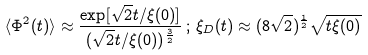Convert formula to latex. <formula><loc_0><loc_0><loc_500><loc_500>\langle \Phi ^ { 2 } ( t ) \rangle \approx \frac { \exp [ \sqrt { 2 } t / \xi ( 0 ) ] } { ( \sqrt { 2 } t / \xi ( 0 ) ) ^ { \frac { 3 } { 2 } } } \, ; \, \xi _ { D } ( t ) \approx ( 8 \sqrt { 2 } ) ^ { \frac { 1 } { 2 } } \sqrt { t \xi ( 0 ) }</formula> 